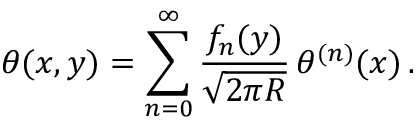<formula> <loc_0><loc_0><loc_500><loc_500>\theta ( x , y ) = \sum _ { n = 0 } ^ { \infty } \frac { f _ { n } ( y ) } { \sqrt { 2 \pi R } } \, \theta ^ { ( n ) } ( x ) \, .</formula> 